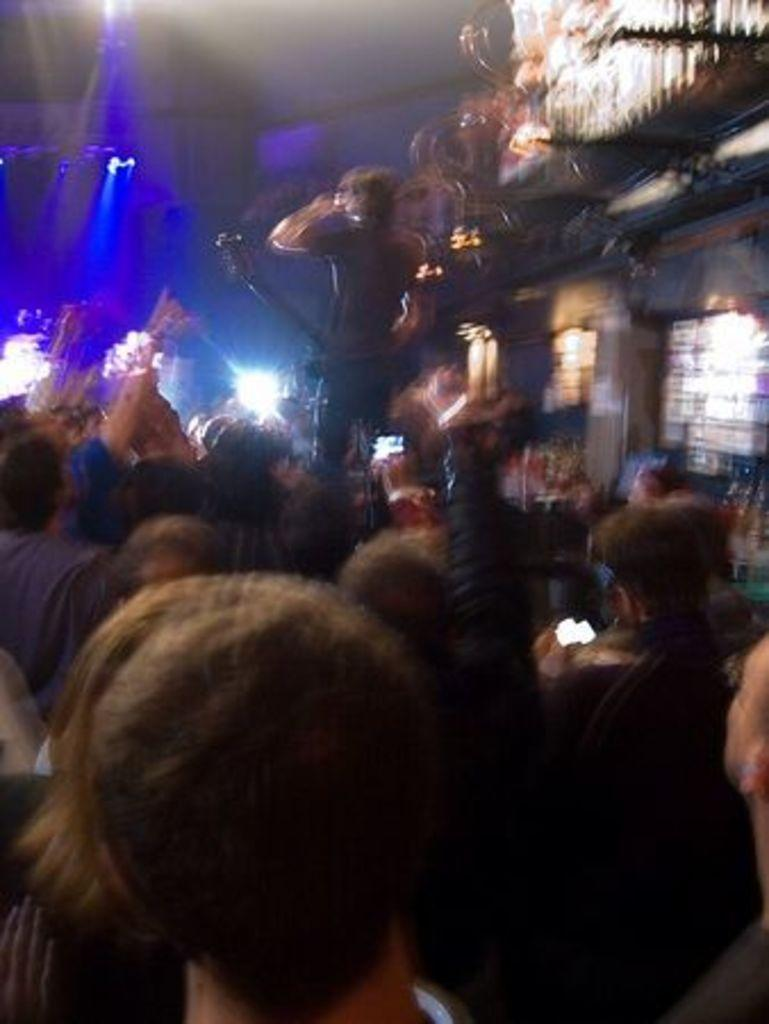How many people are present in the image? There is a group of people standing in the image, but the exact number cannot be determined from the provided facts. What can be seen in the background of the image? There are lights visible in the background of the image. What type of clouds can be seen in the throat of the person in the image? There is no person with a visible throat in the image, and there are no clouds present. 